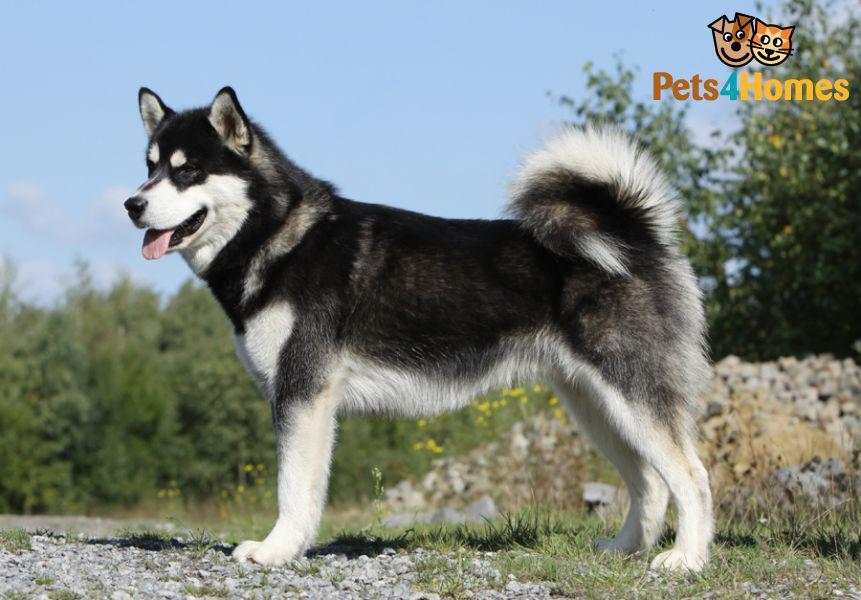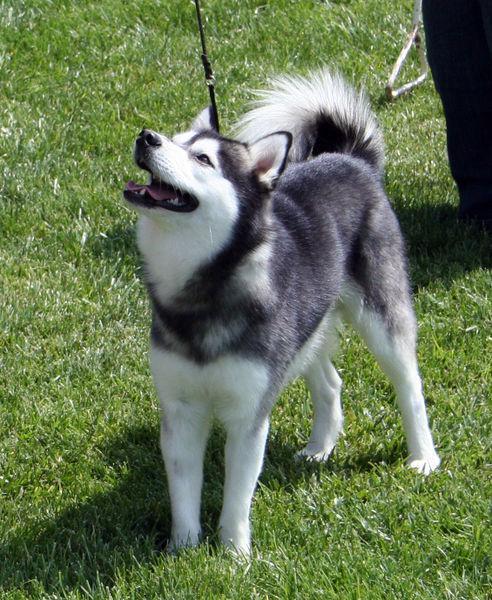The first image is the image on the left, the second image is the image on the right. Assess this claim about the two images: "The right image contains one dog attached to a leash.". Correct or not? Answer yes or no. Yes. The first image is the image on the left, the second image is the image on the right. For the images displayed, is the sentence "Each image shows a husky standing on all fours, and the dog on the right wears a leash." factually correct? Answer yes or no. Yes. 